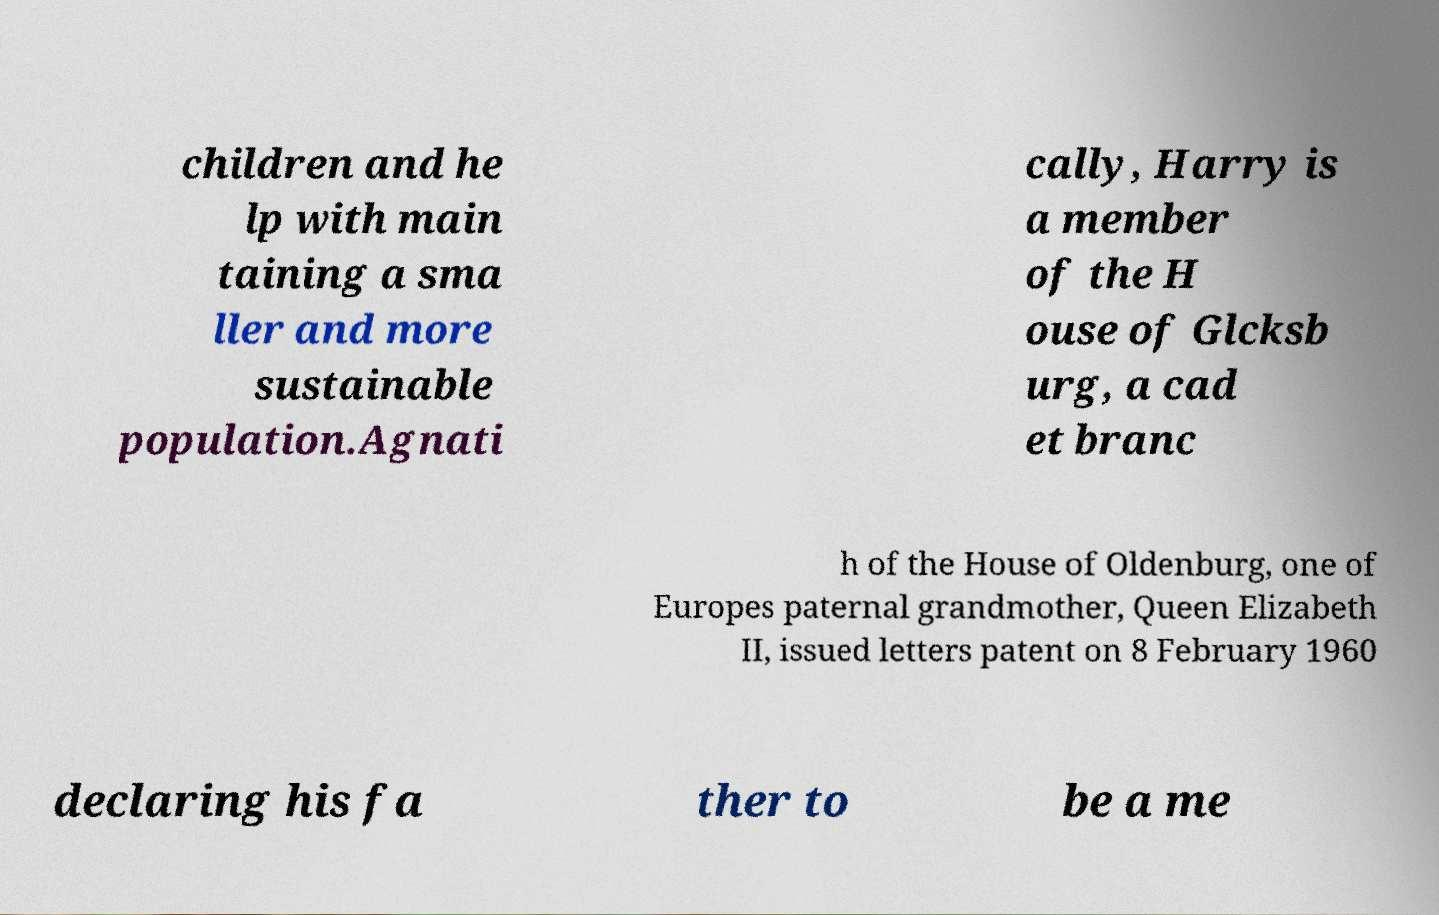Could you extract and type out the text from this image? children and he lp with main taining a sma ller and more sustainable population.Agnati cally, Harry is a member of the H ouse of Glcksb urg, a cad et branc h of the House of Oldenburg, one of Europes paternal grandmother, Queen Elizabeth II, issued letters patent on 8 February 1960 declaring his fa ther to be a me 